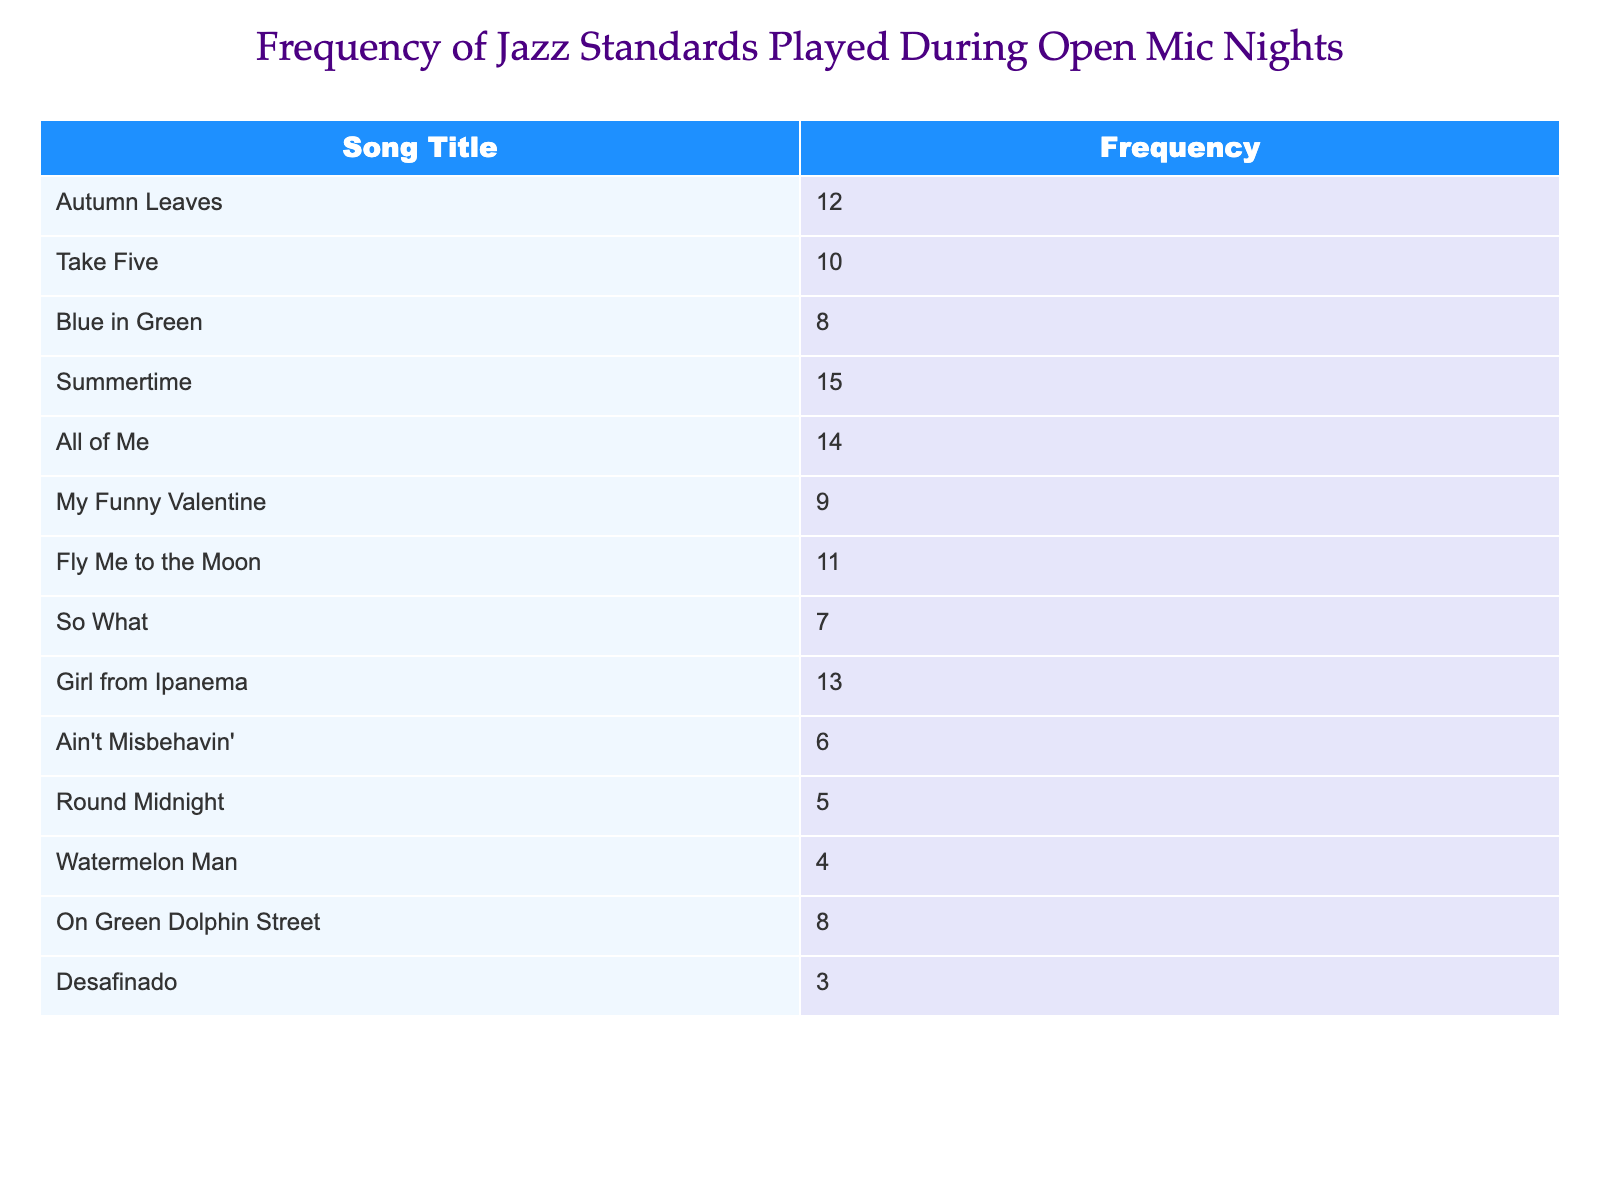What is the frequency of "Summertime"? The table lists "Summertime" with a frequency of 15.
Answer: 15 Which song is played more frequently: "Ain't Misbehavin'" or "Round Midnight"? "Ain't Misbehavin'" has a frequency of 6, while "Round Midnight" has a frequency of 5. Since 6 is greater than 5, "Ain't Misbehavin'" is played more frequently.
Answer: Ain't Misbehavin' What is the total frequency of the songs listed in the table? To find the total, we sum the frequencies: 12 + 10 + 8 + 15 + 14 + 9 + 11 + 7 + 13 + 6 + 5 + 4 + 8 + 3 =  106.
Answer: 106 Is "Fly Me to the Moon" played more than "Desafinado"? "Fly Me to the Moon" has a frequency of 11, while "Desafinado" has a frequency of 3. Since 11 is greater than 3, the statement is true.
Answer: Yes What is the average frequency of songs in the table? There are 14 songs listed. The total frequency is 106. The average is calculated as 106 divided by 14, resulting in approximately 7.57.
Answer: 7.57 How many songs are played with a frequency less than 8? The songs with frequencies less than 8 are "So What" (7), "Ain't Misbehavin'" (6), "Round Midnight" (5), "Watermelon Man" (4), and "Desafinado" (3). This gives us a total of 5 songs.
Answer: 5 Which song is the least often played? The table indicates that "Desafinado" has the lowest frequency at 3.
Answer: Desafinado What is the difference in frequency between the most and least played songs? The most played song is "Summertime" with a frequency of 15, and the least played is "Desafinado" with a frequency of 3. The difference is 15 - 3 = 12.
Answer: 12 How many songs have a frequency of 10 or more? The songs with a frequency of 10 or more are "Autumn Leaves" (12), "Take Five" (10), "Summertime" (15), "All of Me" (14), "Fly Me to the Moon" (11), "Girl from Ipanema" (13). This makes for a total of 6 songs.
Answer: 6 